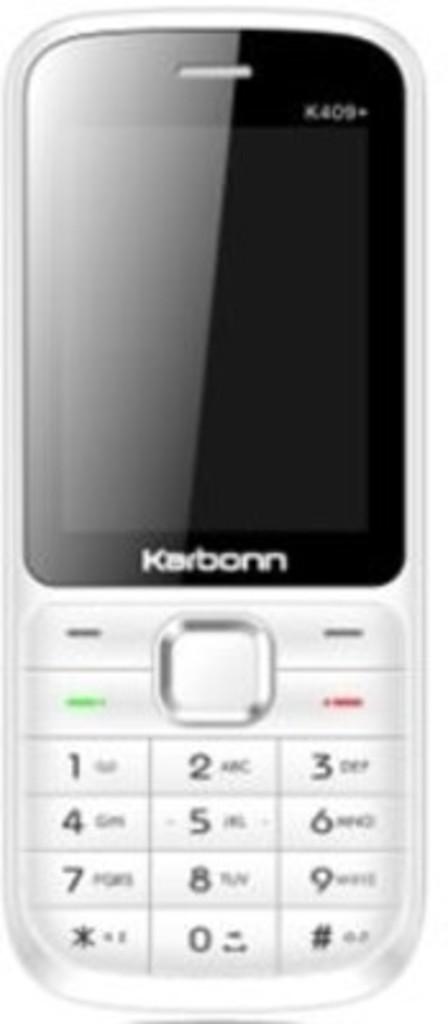What kind of phone is this?
Offer a terse response. Karbonn. What number is in the middle on the bottom?
Keep it short and to the point. 0. 